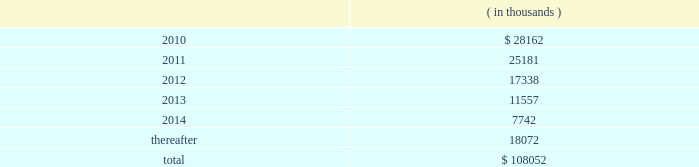There were no changes in the company 2019s valuation techniques used to measure fair values on a recurring basis as a result of adopting asc 820 .
Pca had no assets or liabilities that were measured on a nonrecurring basis .
11 .
Stockholders 2019 equity on october 17 , 2007 , pca announced that its board of directors authorized a $ 150.0 million common stock repurchase program .
There is no expiration date for the common stock repurchase program .
Through december 31 , 2008 , the company repurchased 3818729 shares of common stock , with 3142600 shares repurchased during 2008 and 676129 shares repurchased during 2007 .
All repurchased shares were retired prior to december 31 , 2008 .
There were no shares repurchased in 2009 .
As of december 31 , 2009 , $ 65.0 million of the $ 150.0 million authorization remained available for repurchase of the company 2019s common stock .
12 .
Commitments and contingencies capital commitments the company had authorized capital commitments of approximately $ 41.7 million and $ 43.0 million as of december 31 , 2009 and 2008 , respectively , in connection with the expansion and replacement of existing facilities and equipment .
In addition , commitments at december 31 , 2009 for the major energy optimization projects at its counce and valdosta mills totaled $ 156.3 million .
Lease obligations pca leases space for certain of its facilities and cutting rights to approximately 91000 acres of timberland under long-term leases .
The company also leases equipment , primarily vehicles and rolling stock , and other assets under long-term leases with a duration of two to seven years .
The minimum lease payments under non-cancelable operating leases with lease terms in excess of one year are as follows: .
Total lease expense , including base rent on all leases and executory costs , such as insurance , taxes , and maintenance , for the years ended december 31 , 2009 , 2008 and 2007 was $ 41.3 million , $ 41.6 million and $ 39.8 million , respectively .
These costs are included in cost of goods sold and selling and administrative expenses .
Pca was obligated under capital leases covering buildings and machinery and equipment in the amount of $ 23.1 million and $ 23.7 million at december 31 , 2009 and 2008 , respectively .
During the fourth quarter of 2008 , the company entered into a capital lease relating to buildings and machinery , totaling $ 23.9 million , payable over 20 years .
This capital lease amount is a non-cash transaction and , accordingly , has been excluded packaging corporation of america notes to consolidated financial statements ( continued ) december 31 , 2009 .
What percentage of total minimum lease payments under non-cancelable operating leases with lease terms in excess of one year are due in 2011? 
Computations: (25181 / 108052)
Answer: 0.23305. 